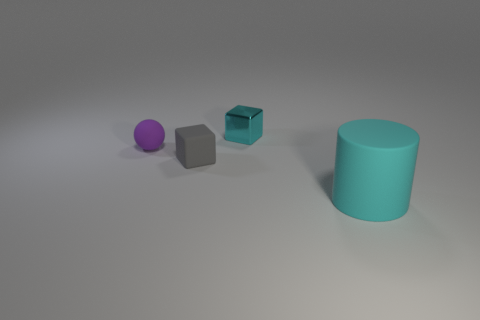There is a cube left of the tiny block on the right side of the gray matte object; how big is it?
Ensure brevity in your answer.  Small. What is the material of the cyan object that is the same shape as the gray rubber thing?
Make the answer very short. Metal. What number of shiny blocks are the same size as the sphere?
Provide a succinct answer. 1. Do the gray cube and the cylinder have the same size?
Offer a terse response. No. There is a rubber object that is both on the left side of the cyan metallic object and right of the purple rubber sphere; what is its size?
Offer a terse response. Small. Are there more tiny matte things to the left of the gray object than purple rubber spheres that are to the right of the tiny cyan cube?
Ensure brevity in your answer.  Yes. There is a tiny rubber object that is the same shape as the tiny cyan metallic thing; what is its color?
Your answer should be very brief. Gray. There is a object right of the cyan metallic cube; does it have the same color as the small shiny object?
Ensure brevity in your answer.  Yes. What number of big red metal blocks are there?
Keep it short and to the point. 0. Are the object in front of the tiny gray object and the small gray block made of the same material?
Your response must be concise. Yes. 